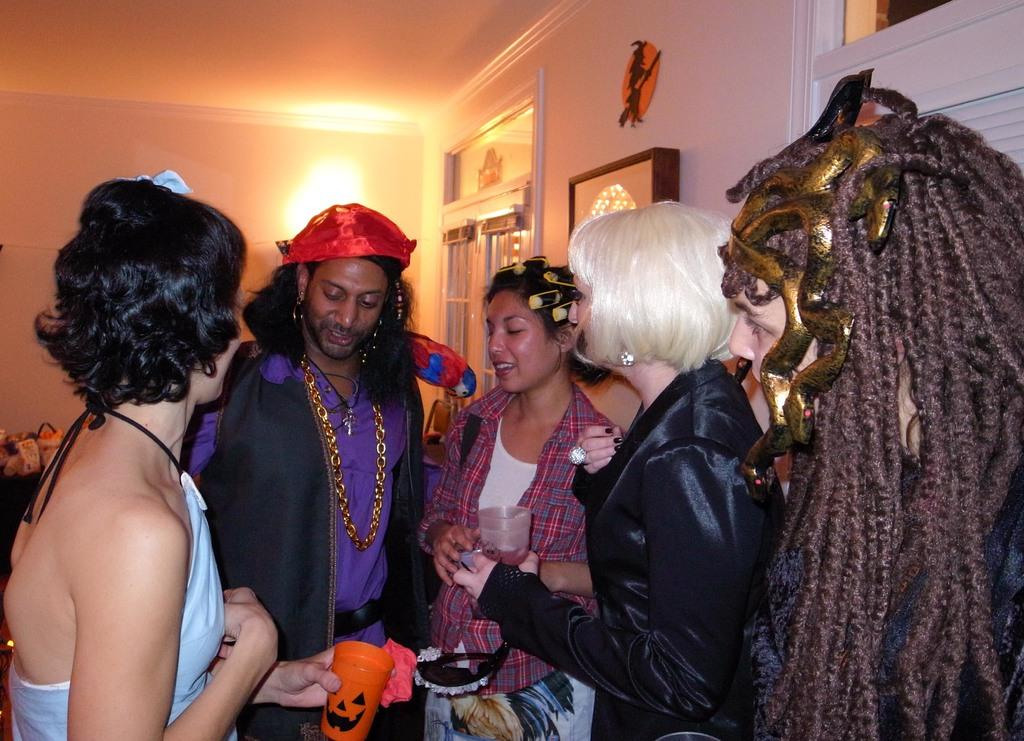How many people are present in the image? There are five people standing in the image. What are the people holding in the image? The people are holding objects. Can you describe the lighting in the image? There is a light visible in the image. What architectural feature can be seen in the image? There is a window in the image. What is attached to the wall in the image? There is a photo frame and an object attached to the wall. What type of company is depicted in the scene in the image? There is no scene or company depicted in the image; it features five people standing and holding objects. What is the value of the cent in the image? There is no cent present in the image. 